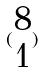Convert formula to latex. <formula><loc_0><loc_0><loc_500><loc_500>( \begin{matrix} 8 \\ 1 \end{matrix} )</formula> 